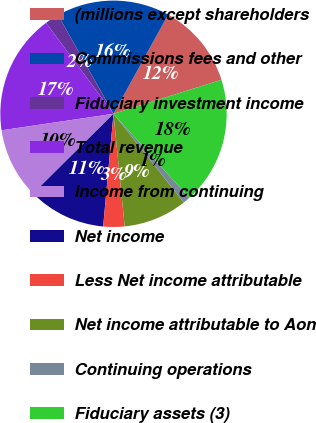<chart> <loc_0><loc_0><loc_500><loc_500><pie_chart><fcel>(millions except shareholders<fcel>Commissions fees and other<fcel>Fiduciary investment income<fcel>Total revenue<fcel>Income from continuing<fcel>Net income<fcel>Less Net income attributable<fcel>Net income attributable to Aon<fcel>Continuing operations<fcel>Fiduciary assets (3)<nl><fcel>12.12%<fcel>16.16%<fcel>2.02%<fcel>17.17%<fcel>10.1%<fcel>11.11%<fcel>3.03%<fcel>9.09%<fcel>1.01%<fcel>18.18%<nl></chart> 